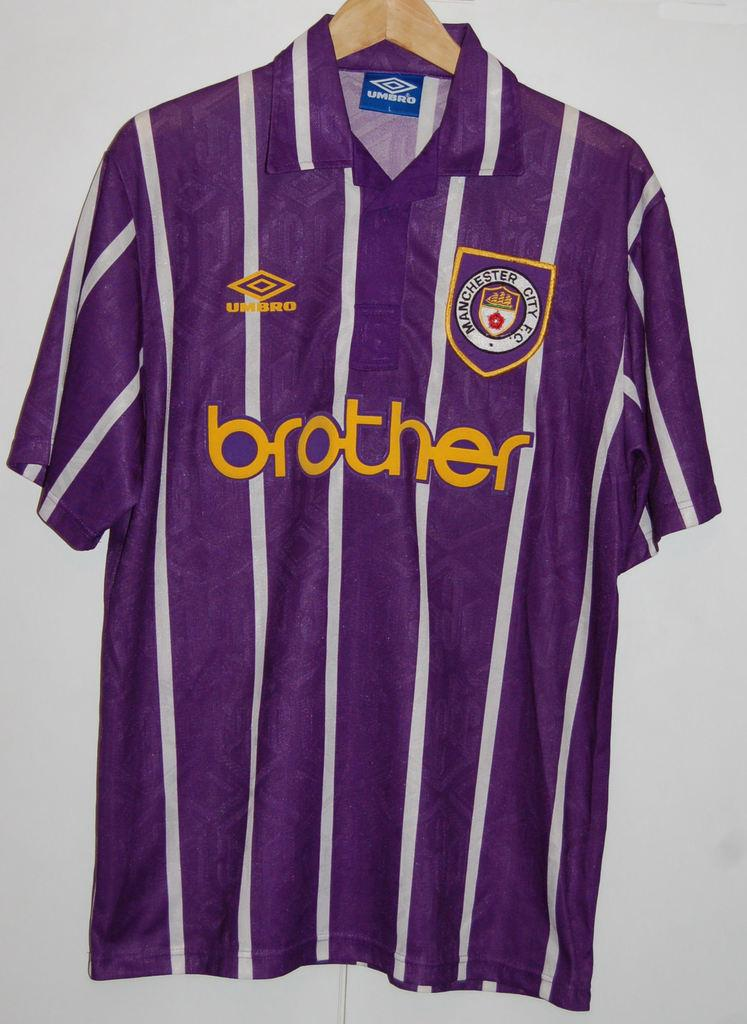<image>
Summarize the visual content of the image. A purple shirt with white stripes and the word brother across the chest. 